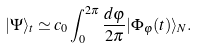<formula> <loc_0><loc_0><loc_500><loc_500>| \Psi \rangle _ { t } \simeq c _ { 0 } \int _ { 0 } ^ { 2 \pi } \frac { d \varphi } { 2 \pi } | \Phi _ { \varphi } ( t ) \rangle _ { N } .</formula> 